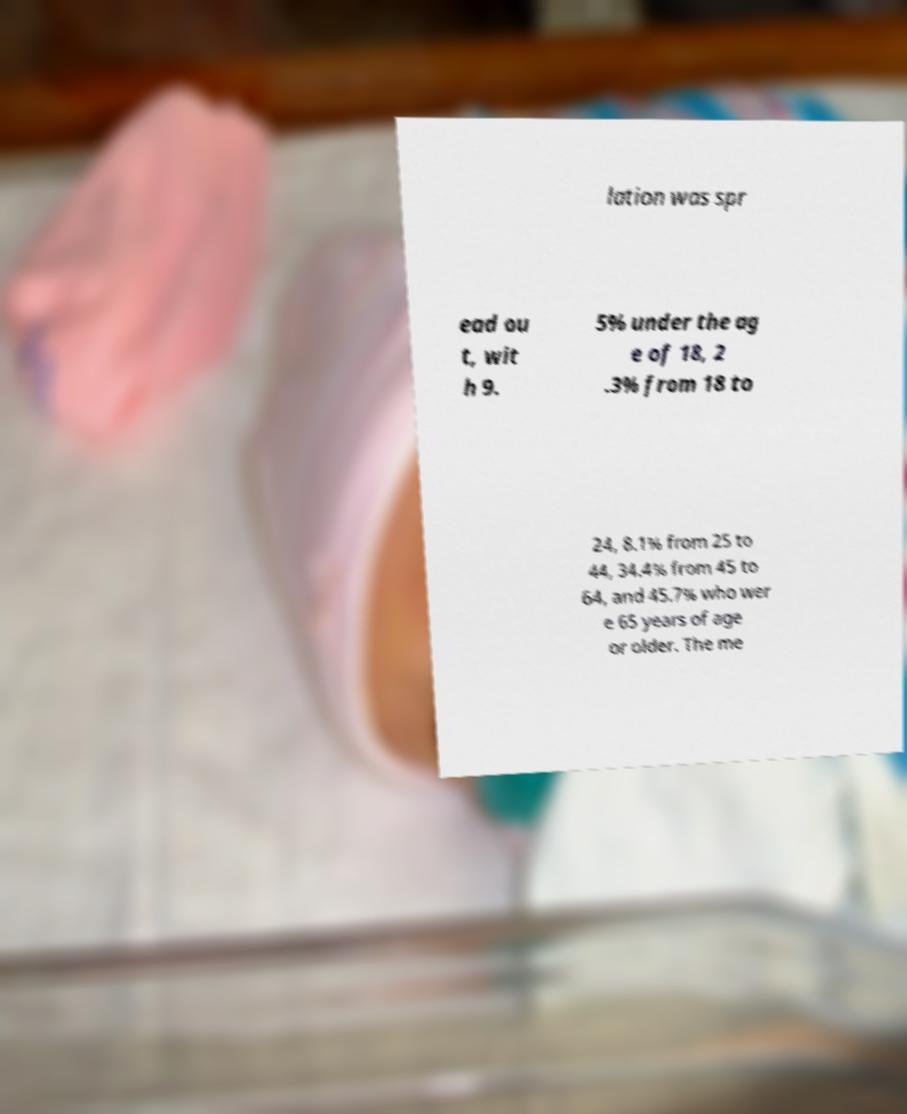Could you extract and type out the text from this image? lation was spr ead ou t, wit h 9. 5% under the ag e of 18, 2 .3% from 18 to 24, 8.1% from 25 to 44, 34.4% from 45 to 64, and 45.7% who wer e 65 years of age or older. The me 